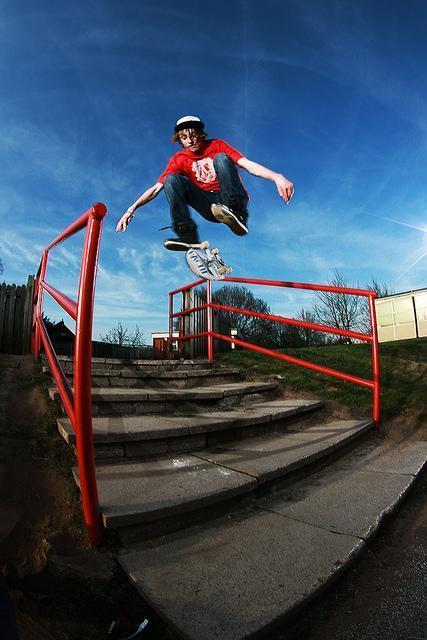How many steps are in the picture?
Give a very brief answer. 6. How many baby sheep are there in the center of the photo beneath the adult sheep?
Give a very brief answer. 0. 